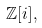Convert formula to latex. <formula><loc_0><loc_0><loc_500><loc_500>\mathbb { Z } [ i ] ,</formula> 